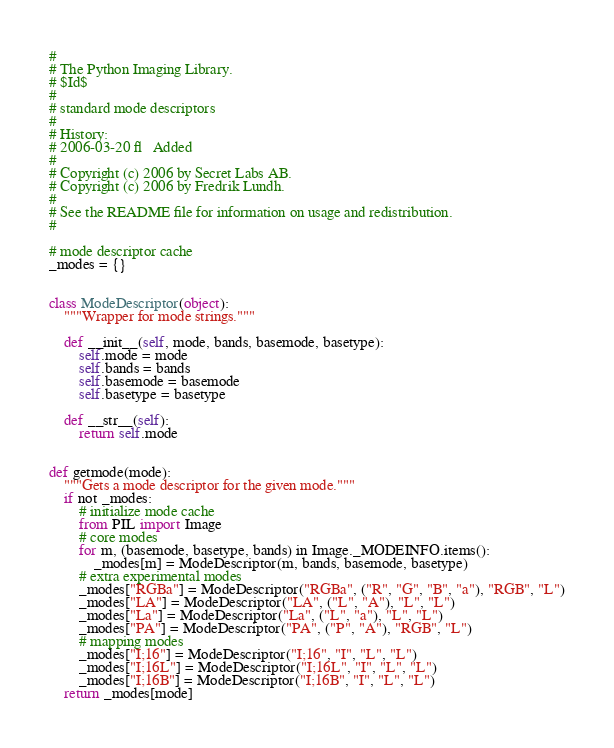<code> <loc_0><loc_0><loc_500><loc_500><_Python_>#
# The Python Imaging Library.
# $Id$
#
# standard mode descriptors
#
# History:
# 2006-03-20 fl   Added
#
# Copyright (c) 2006 by Secret Labs AB.
# Copyright (c) 2006 by Fredrik Lundh.
#
# See the README file for information on usage and redistribution.
#

# mode descriptor cache
_modes = {}


class ModeDescriptor(object):
    """Wrapper for mode strings."""

    def __init__(self, mode, bands, basemode, basetype):
        self.mode = mode
        self.bands = bands
        self.basemode = basemode
        self.basetype = basetype

    def __str__(self):
        return self.mode


def getmode(mode):
    """Gets a mode descriptor for the given mode."""
    if not _modes:
        # initialize mode cache
        from PIL import Image
        # core modes
        for m, (basemode, basetype, bands) in Image._MODEINFO.items():
            _modes[m] = ModeDescriptor(m, bands, basemode, basetype)
        # extra experimental modes
        _modes["RGBa"] = ModeDescriptor("RGBa", ("R", "G", "B", "a"), "RGB", "L")
        _modes["LA"] = ModeDescriptor("LA", ("L", "A"), "L", "L")
        _modes["La"] = ModeDescriptor("La", ("L", "a"), "L", "L")
        _modes["PA"] = ModeDescriptor("PA", ("P", "A"), "RGB", "L")
        # mapping modes
        _modes["I;16"] = ModeDescriptor("I;16", "I", "L", "L")
        _modes["I;16L"] = ModeDescriptor("I;16L", "I", "L", "L")
        _modes["I;16B"] = ModeDescriptor("I;16B", "I", "L", "L")
    return _modes[mode]
</code> 